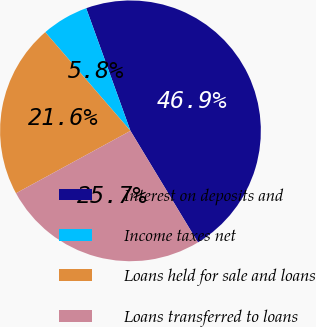Convert chart to OTSL. <chart><loc_0><loc_0><loc_500><loc_500><pie_chart><fcel>Interest on deposits and<fcel>Income taxes net<fcel>Loans held for sale and loans<fcel>Loans transferred to loans<nl><fcel>46.86%<fcel>5.82%<fcel>21.61%<fcel>25.71%<nl></chart> 